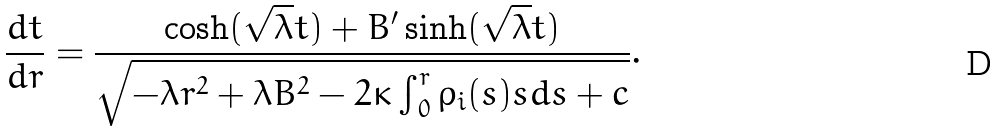Convert formula to latex. <formula><loc_0><loc_0><loc_500><loc_500>\frac { d t } { d r } = \frac { \cosh ( \sqrt { \lambda } t ) + B ^ { \prime } \sinh ( \sqrt { \lambda } t ) } { \sqrt { { - \lambda r ^ { 2 } + \lambda B ^ { 2 } - 2 \kappa \int _ { 0 } ^ { r } { \rho _ { i } ( s ) s d s } + c } } } .</formula> 